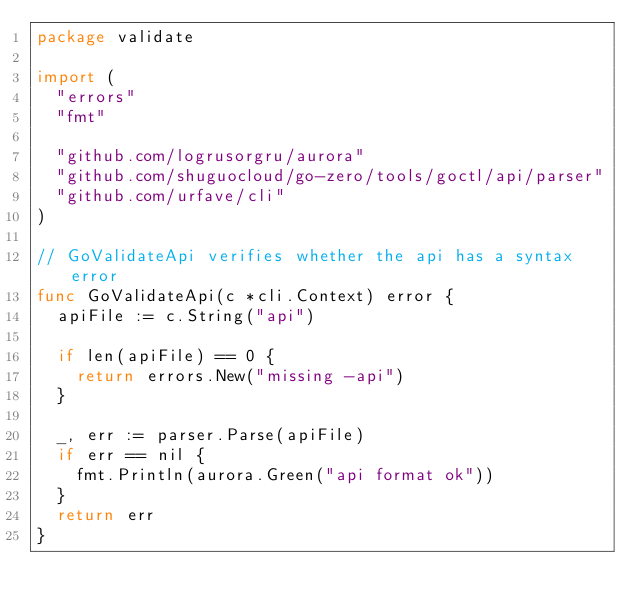Convert code to text. <code><loc_0><loc_0><loc_500><loc_500><_Go_>package validate

import (
	"errors"
	"fmt"

	"github.com/logrusorgru/aurora"
	"github.com/shuguocloud/go-zero/tools/goctl/api/parser"
	"github.com/urfave/cli"
)

// GoValidateApi verifies whether the api has a syntax error
func GoValidateApi(c *cli.Context) error {
	apiFile := c.String("api")

	if len(apiFile) == 0 {
		return errors.New("missing -api")
	}

	_, err := parser.Parse(apiFile)
	if err == nil {
		fmt.Println(aurora.Green("api format ok"))
	}
	return err
}
</code> 